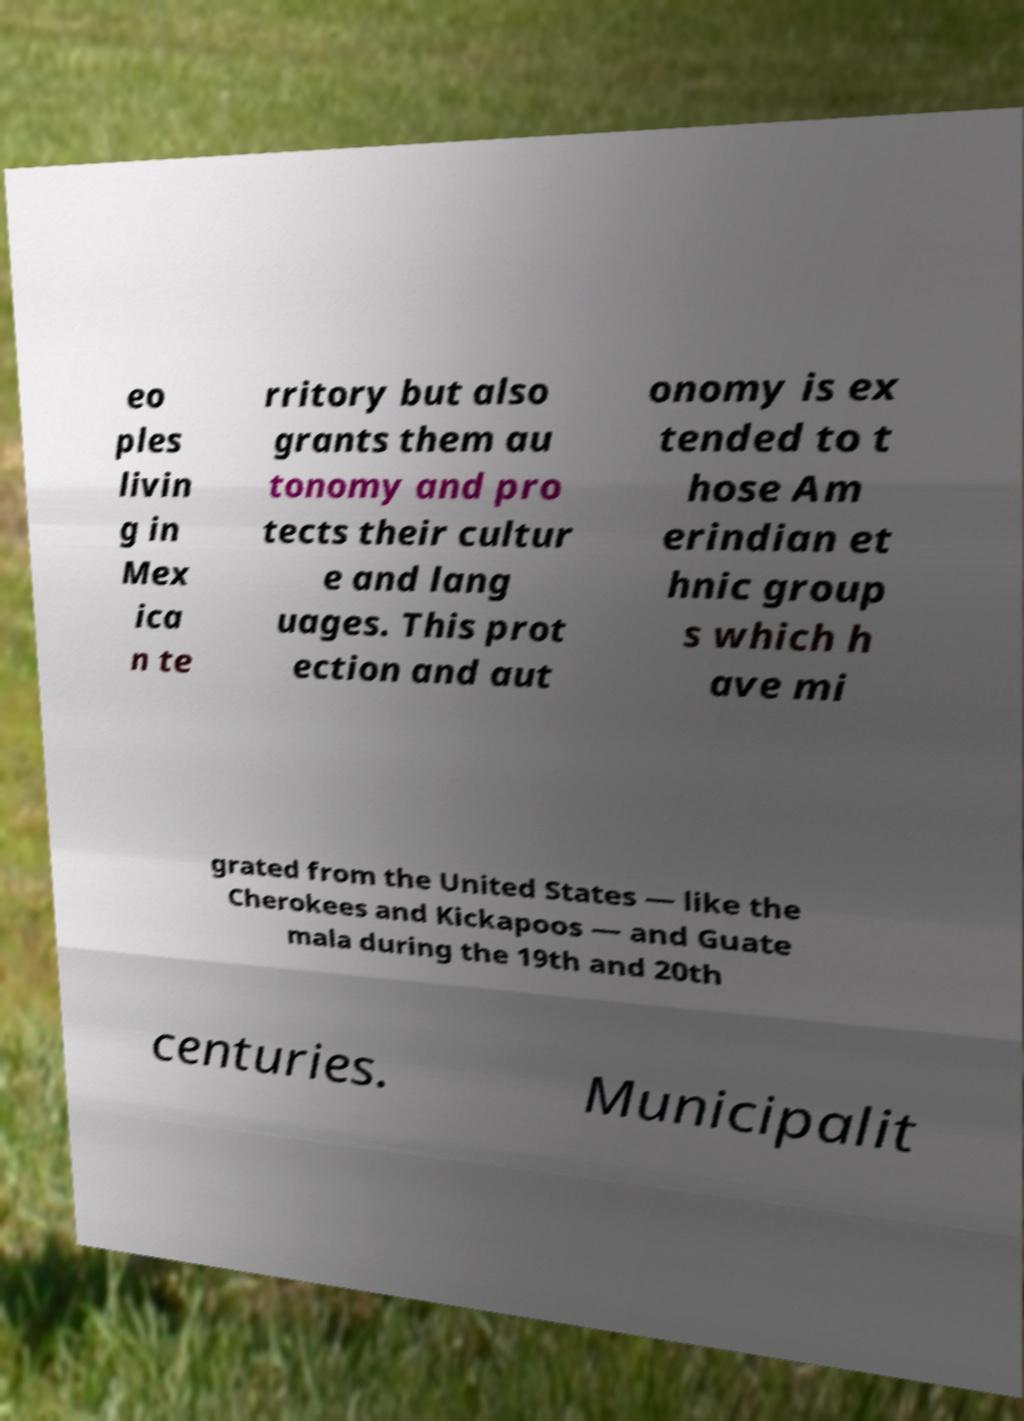There's text embedded in this image that I need extracted. Can you transcribe it verbatim? eo ples livin g in Mex ica n te rritory but also grants them au tonomy and pro tects their cultur e and lang uages. This prot ection and aut onomy is ex tended to t hose Am erindian et hnic group s which h ave mi grated from the United States — like the Cherokees and Kickapoos — and Guate mala during the 19th and 20th centuries. Municipalit 